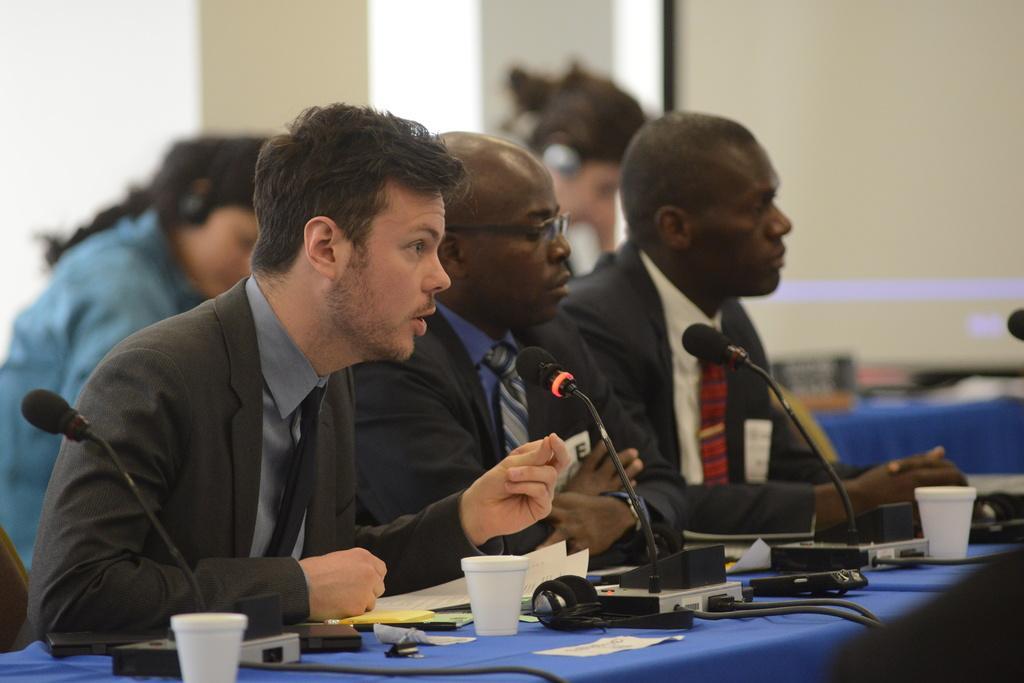In one or two sentences, can you explain what this image depicts? In this picture there are men those who are sitting in front of a table in the image, table contains mics, papers, and glasses on it, there are other people in the background area of the image. 